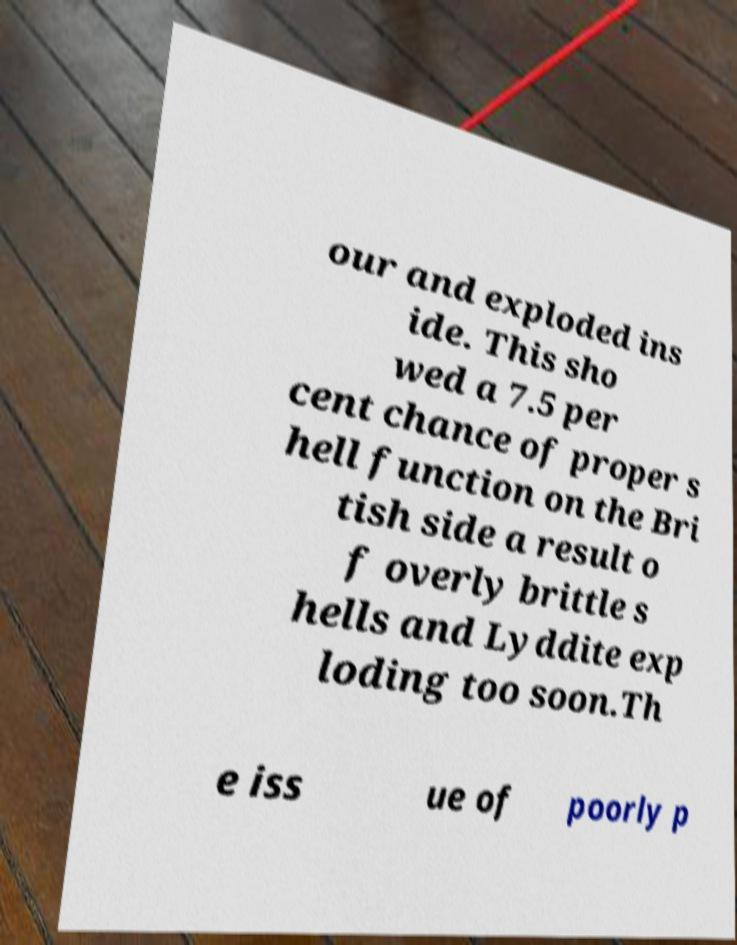Can you read and provide the text displayed in the image?This photo seems to have some interesting text. Can you extract and type it out for me? our and exploded ins ide. This sho wed a 7.5 per cent chance of proper s hell function on the Bri tish side a result o f overly brittle s hells and Lyddite exp loding too soon.Th e iss ue of poorly p 